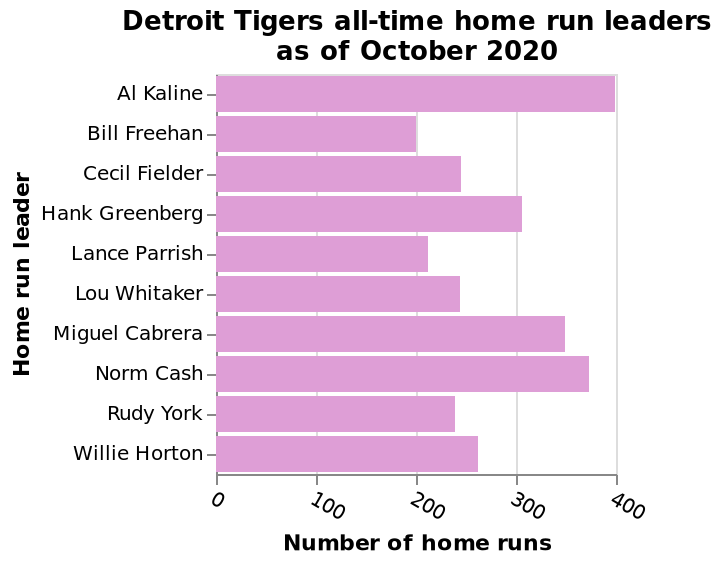<image>
What is the highest number of home runs scored by the Detroit Tigers in all time? 400 is the highest number of home runs the Detroit Tigers have been able to score in all time. Which player has the highest number of home runs for the Detroit Tigers? Al Kaline has the highest number of home runs for the Detroit Tigers. What is the maximum number of home runs represented on the x-axis of the bar plot?  The maximum number of home runs represented on the x-axis of the bar plot is 400. What is the scale used for the x-axis of the bar plot? The scale used for the x-axis of the bar plot is a linear scale with a minimum of 0 and a maximum of 400. please summary the statistics and relations of the chart Al Kaline was the Detroit Tigers leader with the most home runs Norm Cash is second in comparison to Al Kaline who has the highest number of home runs400 is the highest number of home runs, Detroit Tigers have been able to score in al time. 